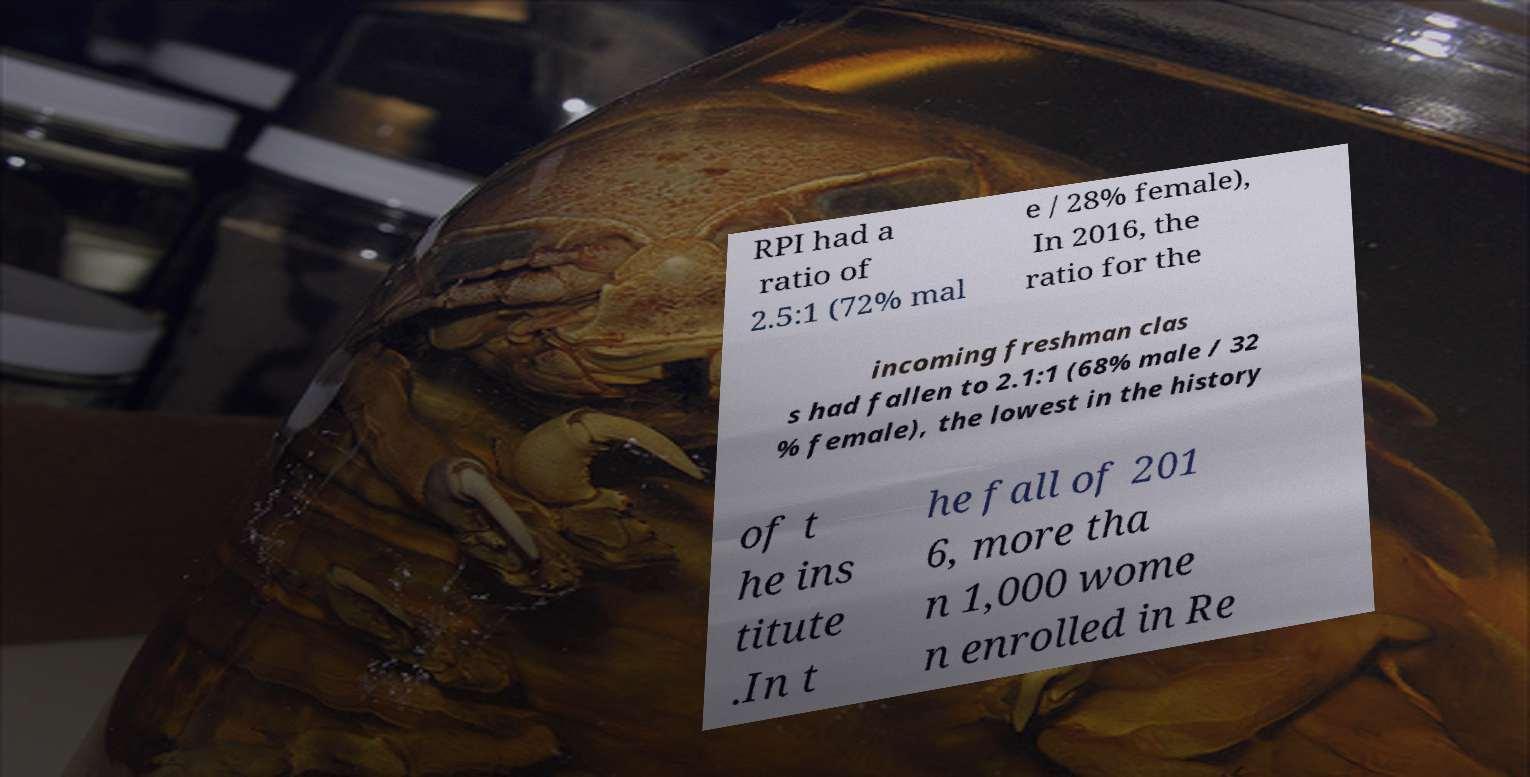Could you assist in decoding the text presented in this image and type it out clearly? RPI had a ratio of 2.5:1 (72% mal e / 28% female), In 2016, the ratio for the incoming freshman clas s had fallen to 2.1:1 (68% male / 32 % female), the lowest in the history of t he ins titute .In t he fall of 201 6, more tha n 1,000 wome n enrolled in Re 